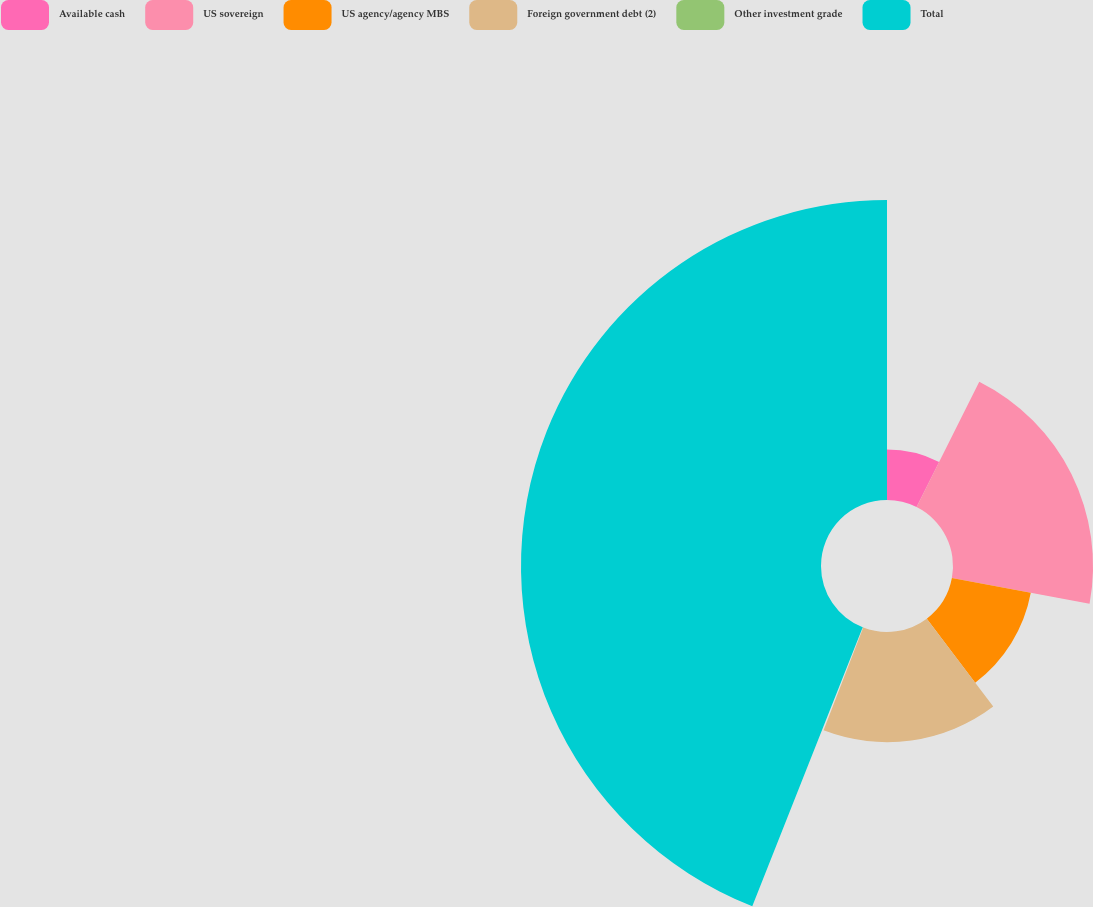<chart> <loc_0><loc_0><loc_500><loc_500><pie_chart><fcel>Available cash<fcel>US sovereign<fcel>US agency/agency MBS<fcel>Foreign government debt (2)<fcel>Other investment grade<fcel>Total<nl><fcel>7.39%<fcel>20.54%<fcel>11.77%<fcel>16.16%<fcel>0.14%<fcel>44.0%<nl></chart> 